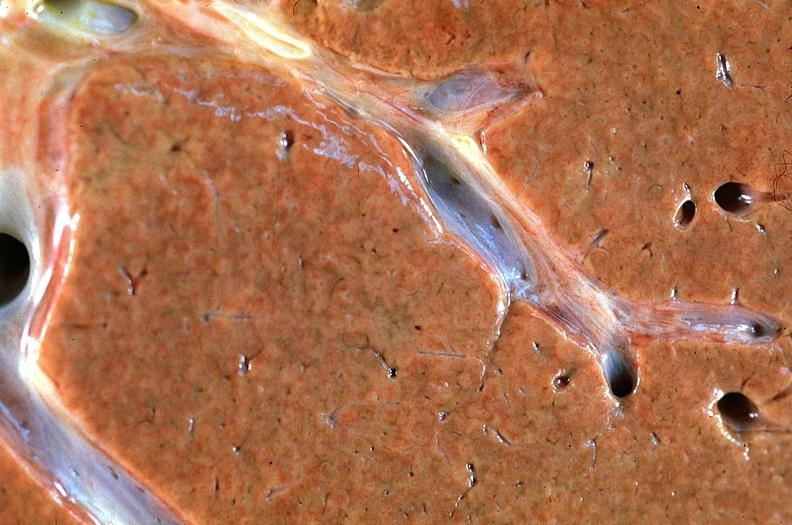what does this image show?
Answer the question using a single word or phrase. Normal liver 